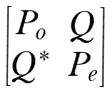Convert formula to latex. <formula><loc_0><loc_0><loc_500><loc_500>\begin{bmatrix} P _ { o } & Q \\ Q ^ { * } & P _ { e } \end{bmatrix}</formula> 